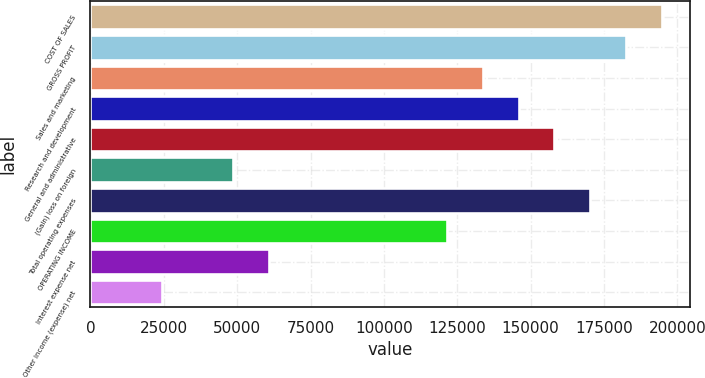Convert chart. <chart><loc_0><loc_0><loc_500><loc_500><bar_chart><fcel>COST OF SALES<fcel>GROSS PROFIT<fcel>Sales and marketing<fcel>Research and development<fcel>General and administrative<fcel>(Gain) loss on foreign<fcel>Total operating expenses<fcel>OPERATING INCOME<fcel>Interest expense net<fcel>Other income (expense) net<nl><fcel>194602<fcel>182439<fcel>133789<fcel>145951<fcel>158114<fcel>48650.5<fcel>170276<fcel>121626<fcel>60813.1<fcel>24325.3<nl></chart> 